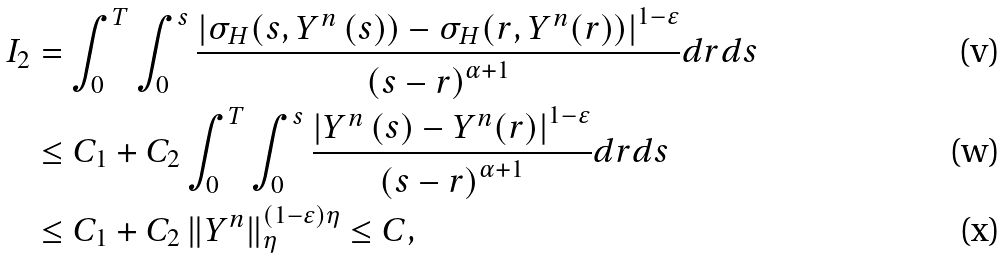Convert formula to latex. <formula><loc_0><loc_0><loc_500><loc_500>I _ { 2 } & = \int _ { 0 } ^ { T } \int _ { 0 } ^ { s } \frac { \left | \sigma _ { H } ( s , Y ^ { n } \left ( s \right ) ) - \sigma _ { H } ( r , Y ^ { n } ( r ) ) \right | ^ { 1 - \varepsilon } } { \left ( s - r \right ) ^ { \alpha + 1 } } d r d s \\ & \leq C _ { 1 } + C _ { 2 } \int _ { 0 } ^ { T } \int _ { 0 } ^ { s } \frac { \left | Y ^ { n } \left ( s \right ) - Y ^ { n } ( r ) \right | ^ { 1 - \varepsilon } } { \left ( s - r \right ) ^ { \alpha + 1 } } d r d s \\ & \leq C _ { 1 } + C _ { 2 } \left \| Y ^ { n } \right \| _ { \eta } ^ { \left ( 1 - \varepsilon \right ) \eta } \leq C ,</formula> 